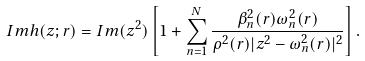<formula> <loc_0><loc_0><loc_500><loc_500>I m h ( z ; { r } ) = I m ( z ^ { 2 } ) \left [ 1 + \sum _ { n = 1 } ^ { N } \frac { \beta _ { n } ^ { 2 } ( { r } ) \omega _ { n } ^ { 2 } ( { r } ) } { \rho ^ { 2 } ( { r } ) | z ^ { 2 } - \omega _ { n } ^ { 2 } ( { r } ) | ^ { 2 } } \right ] .</formula> 